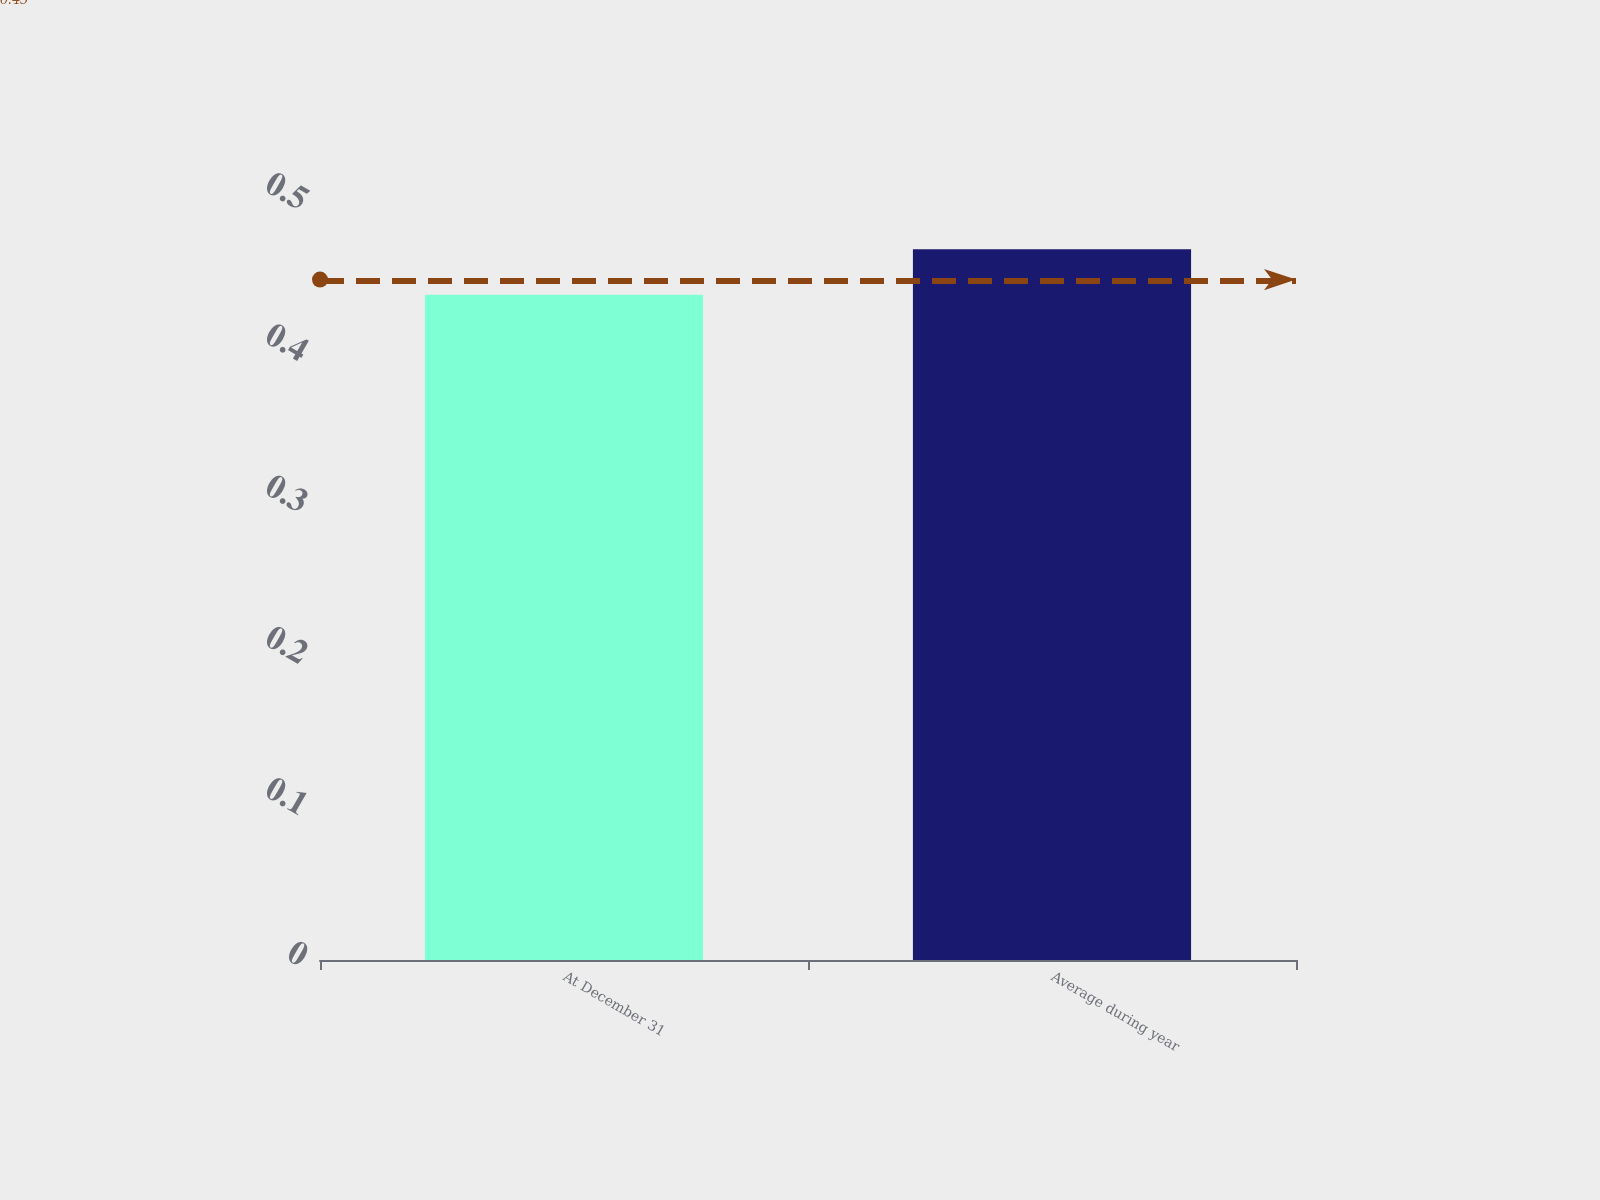<chart> <loc_0><loc_0><loc_500><loc_500><bar_chart><fcel>At December 31<fcel>Average during year<nl><fcel>0.44<fcel>0.47<nl></chart> 